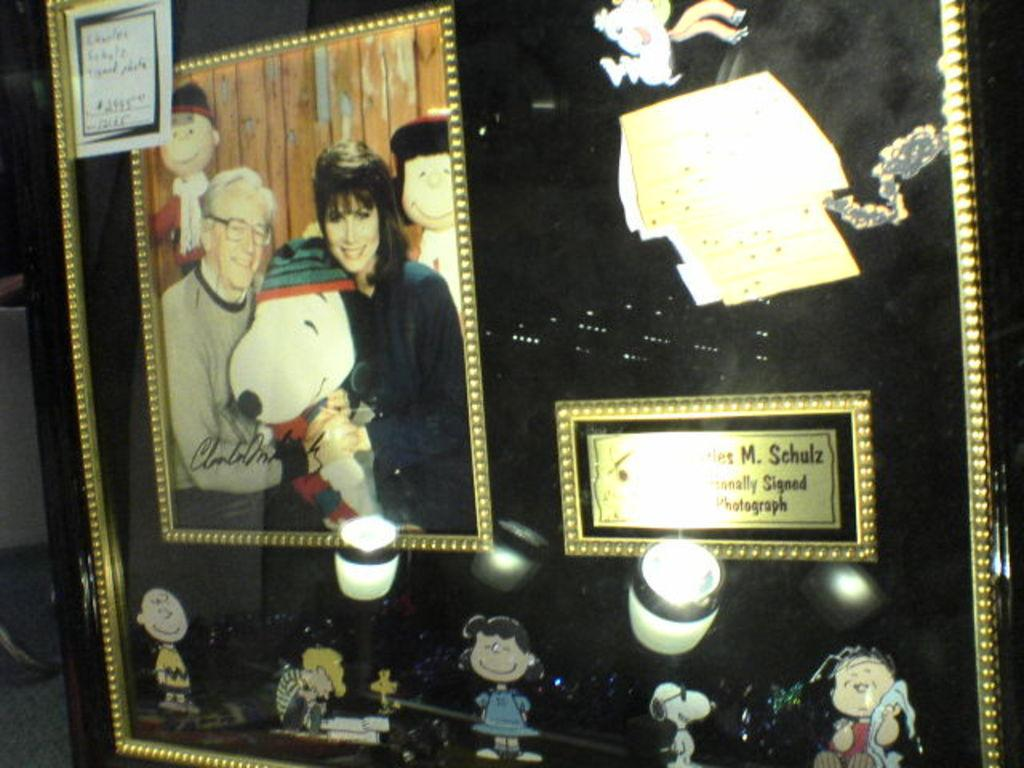What object is present in the image that typically holds a photograph? There is a photo frame in the image. What can be seen inside the photo frame? There are persons standing and smiling in the photo frame, along with cartoon images. Are there any words or phrases written on the photo frame? Yes, there are texts written on the photo frame. Is the alley hot in the image? There is no alley present in the image, so it cannot be determined if it is hot or not. 